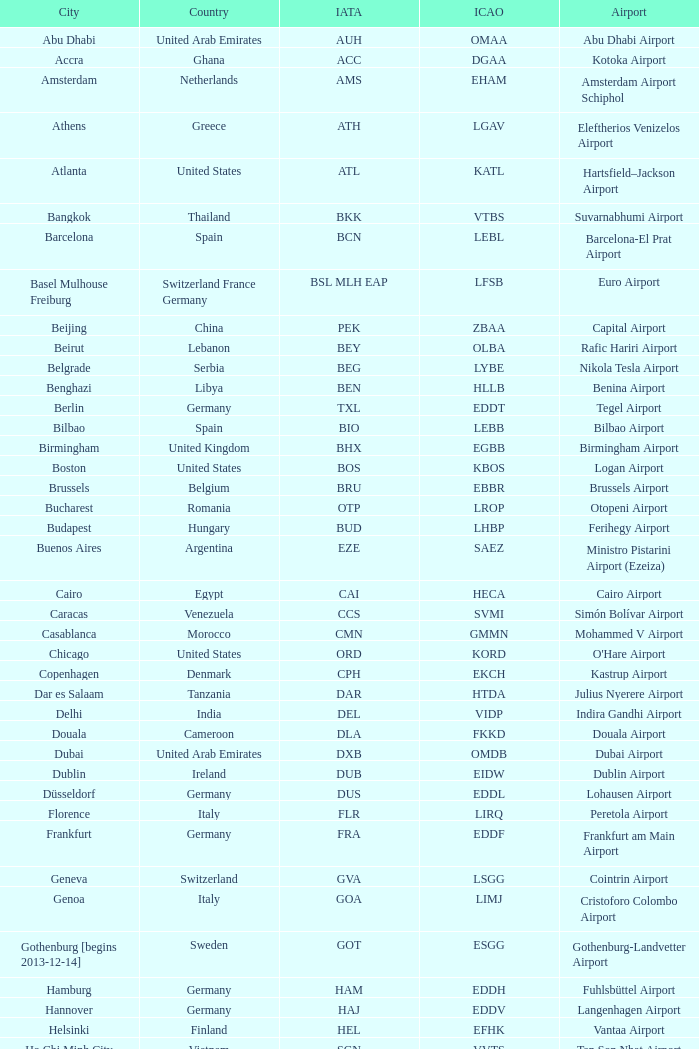What is the ICAO of Lohausen airport? EDDL. 